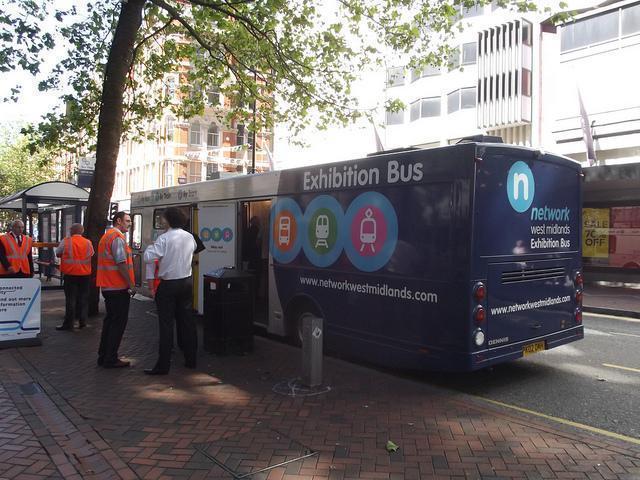What kind of bus is parked in front of the men?
Select the accurate response from the four choices given to answer the question.
Options: Charter, exhibition, school, tour. Exhibition. 